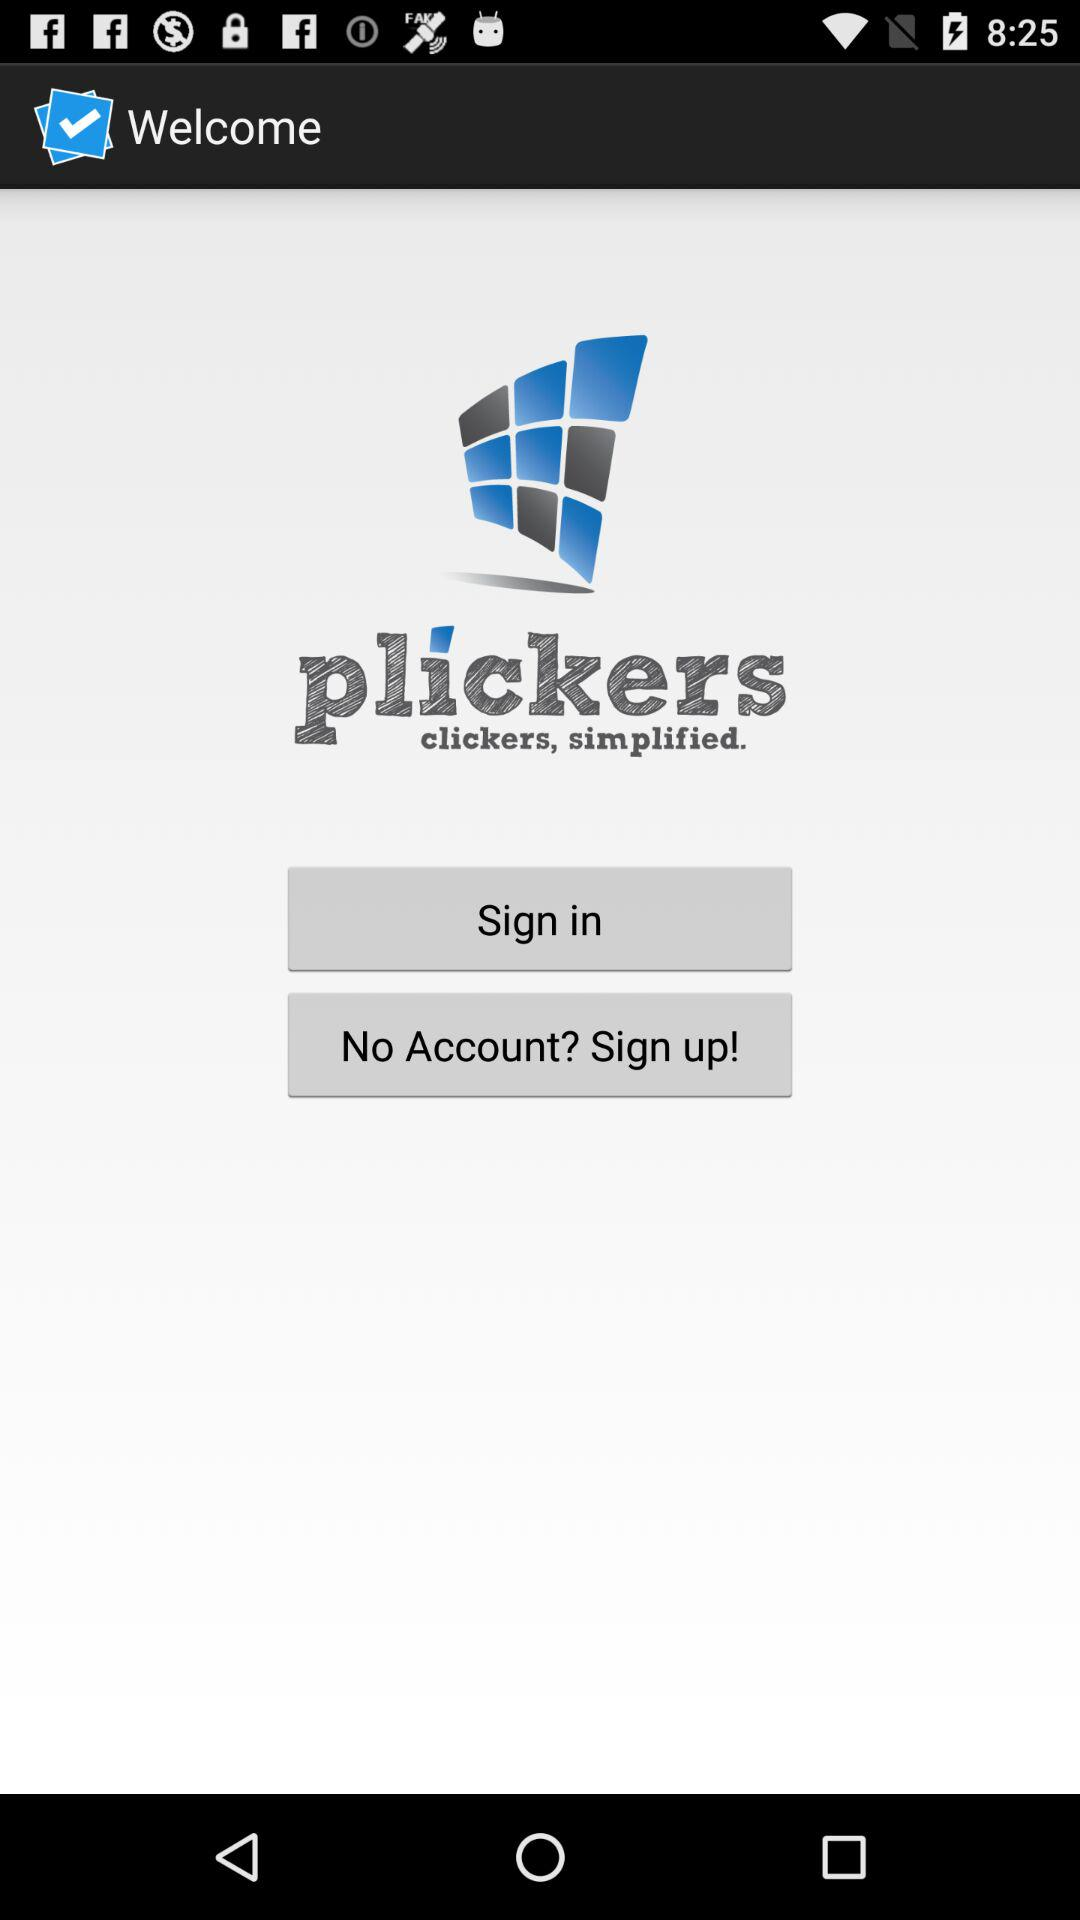What is the name of the application? The name of the application is "plickers". 